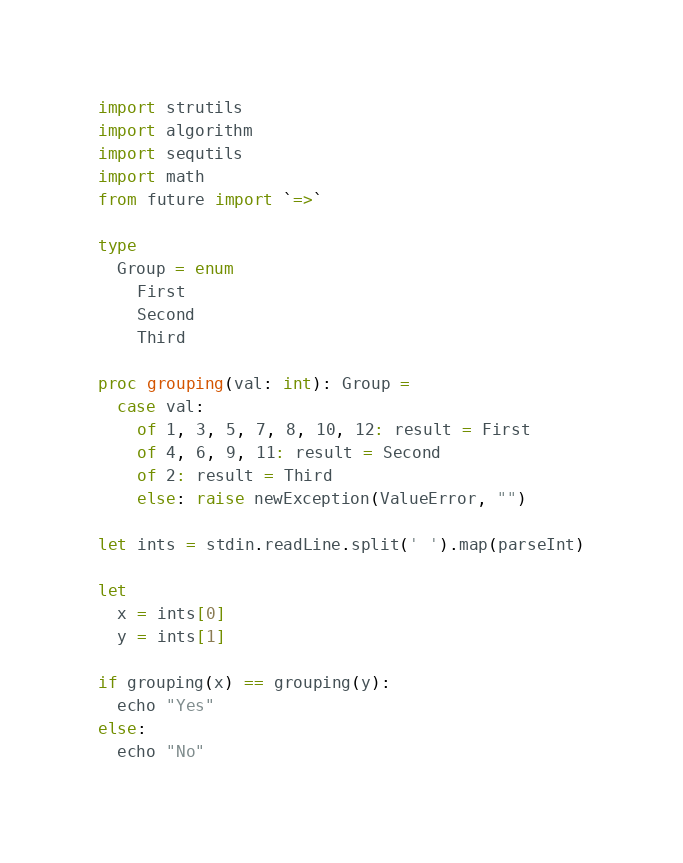<code> <loc_0><loc_0><loc_500><loc_500><_Nim_>import strutils
import algorithm
import sequtils
import math
from future import `=>`

type 
  Group = enum
    First
    Second
    Third

proc grouping(val: int): Group =
  case val:
    of 1, 3, 5, 7, 8, 10, 12: result = First
    of 4, 6, 9, 11: result = Second
    of 2: result = Third
    else: raise newException(ValueError, "")

let ints = stdin.readLine.split(' ').map(parseInt)

let
  x = ints[0]
  y = ints[1]

if grouping(x) == grouping(y):
  echo "Yes"
else:
  echo "No"
</code> 